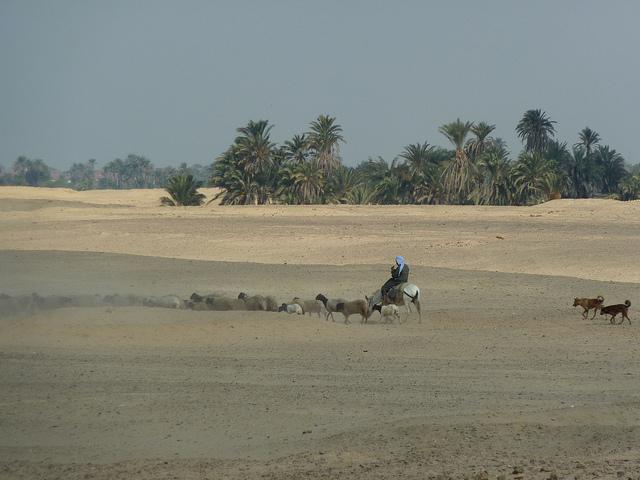Where is the man riding through? desert 